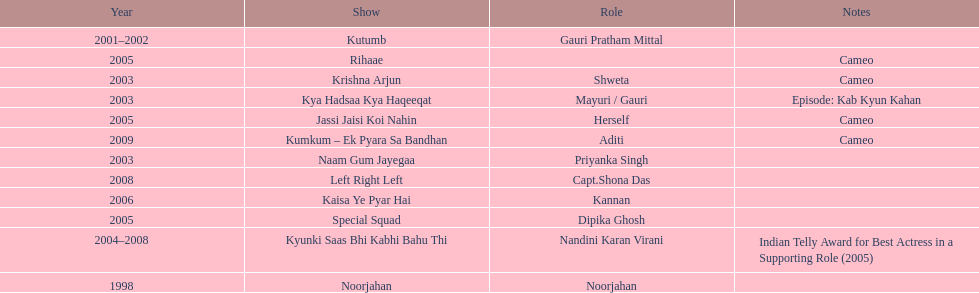In total, how many different tv series has gauri tejwani either starred or cameoed in? 11. 